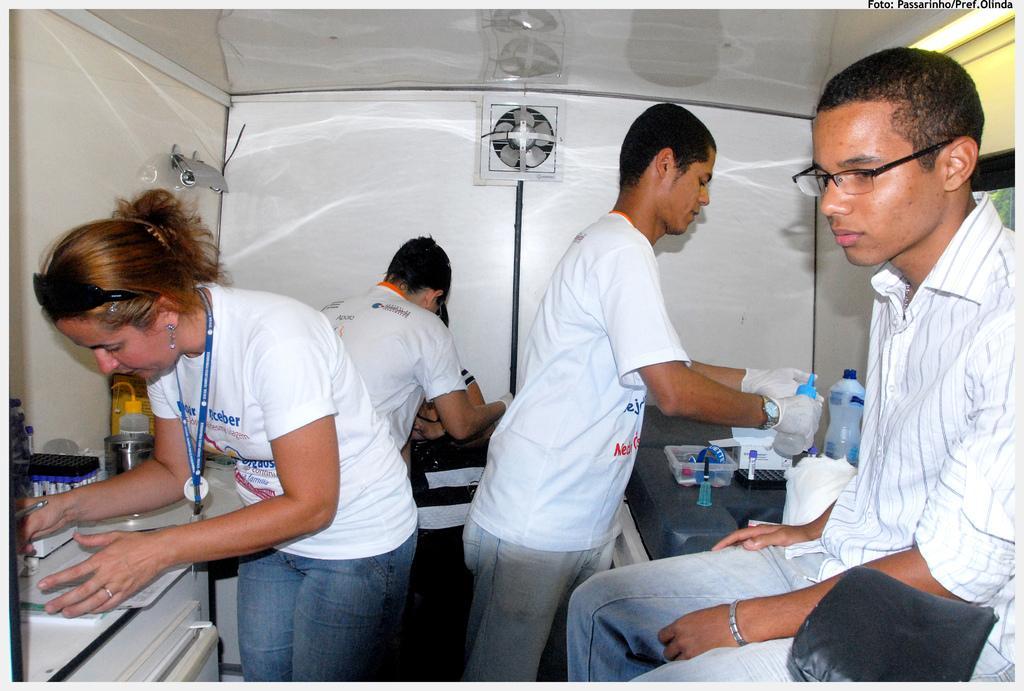Could you give a brief overview of what you see in this image? In the center of the image we can see three people are standing and two persons are sitting. Among them, we can see three people are holding some objects. At the bottom right side of the image, we can see one black color objects. In the background there is a wall, tables, papers, bottles, boxes and a few other objects. 